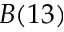Convert formula to latex. <formula><loc_0><loc_0><loc_500><loc_500>B ( 1 3 )</formula> 